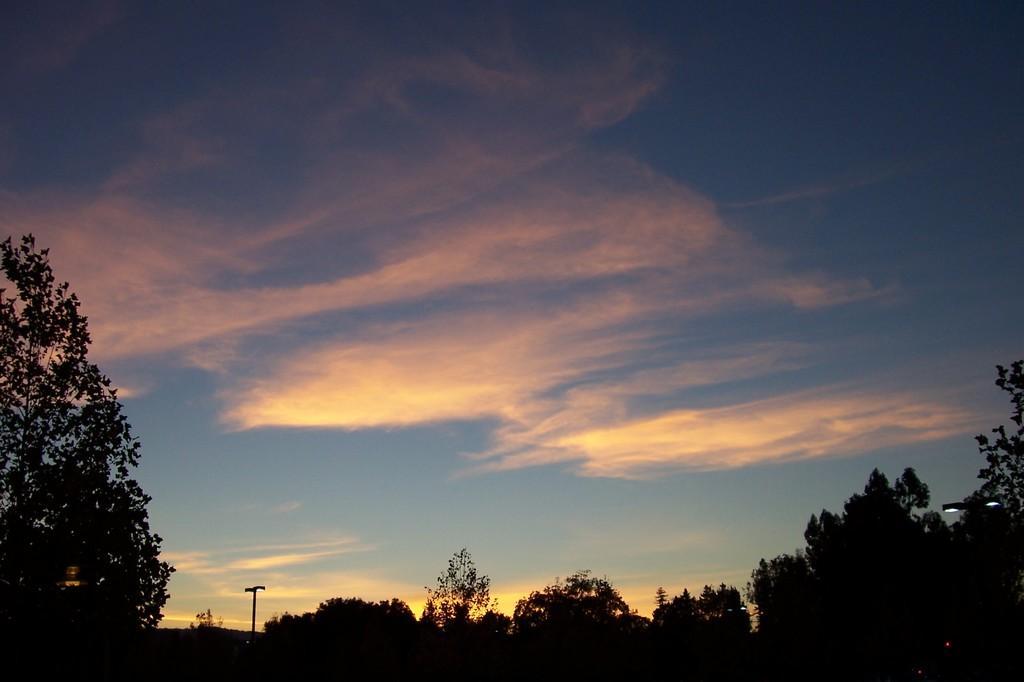How would you summarize this image in a sentence or two? In this image there is the sky, there are clouds in the sky, there is pole, there are street lights, there is a tree truncated towards the left of the image, there is a tree truncated towards the right of the image. 